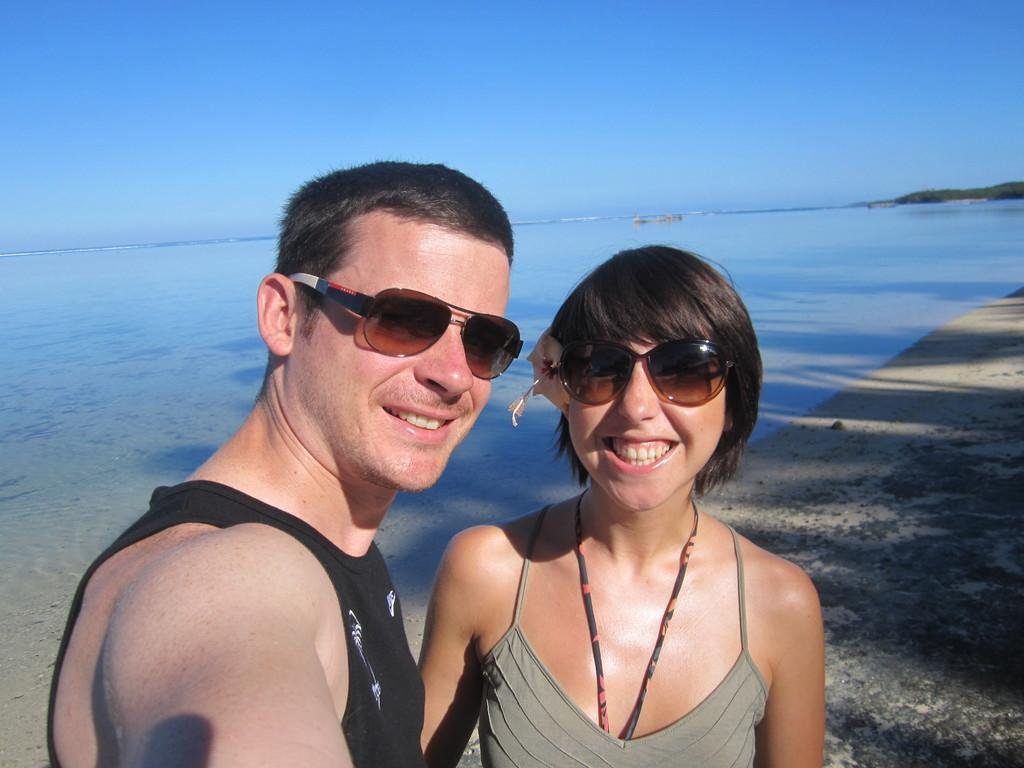Who are the two people in the image? There is a couple in the image. Where are the couple standing? The couple is standing on the sea shore. What can be seen in the background of the image? There is water and an island visible in the image. What is visible at the top of the image? The sky is visible at the top of the image. What type of ear can be seen on the island in the image? There is no ear present on the island or in the image; it is an island with no visible human or animal features. 